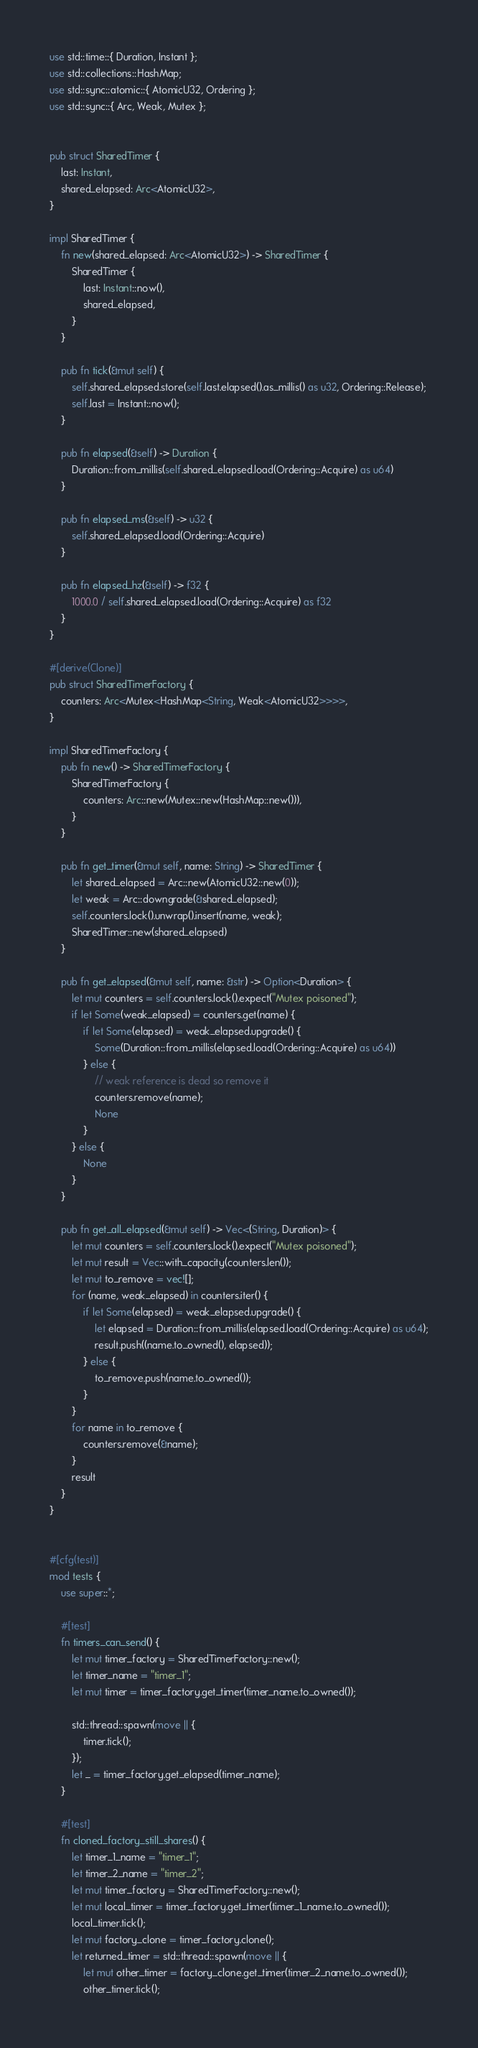Convert code to text. <code><loc_0><loc_0><loc_500><loc_500><_Rust_>use std::time::{ Duration, Instant };
use std::collections::HashMap;
use std::sync::atomic::{ AtomicU32, Ordering };
use std::sync::{ Arc, Weak, Mutex };


pub struct SharedTimer {
    last: Instant,
    shared_elapsed: Arc<AtomicU32>,
}

impl SharedTimer {
    fn new(shared_elapsed: Arc<AtomicU32>) -> SharedTimer {
        SharedTimer {
            last: Instant::now(),
            shared_elapsed,
        }
    }

    pub fn tick(&mut self) {
        self.shared_elapsed.store(self.last.elapsed().as_millis() as u32, Ordering::Release);
        self.last = Instant::now();
    }

    pub fn elapsed(&self) -> Duration {
        Duration::from_millis(self.shared_elapsed.load(Ordering::Acquire) as u64)
    }

    pub fn elapsed_ms(&self) -> u32 {
        self.shared_elapsed.load(Ordering::Acquire)
    }

    pub fn elapsed_hz(&self) -> f32 {
        1000.0 / self.shared_elapsed.load(Ordering::Acquire) as f32
    }
}

#[derive(Clone)]
pub struct SharedTimerFactory {
    counters: Arc<Mutex<HashMap<String, Weak<AtomicU32>>>>,
}

impl SharedTimerFactory {
    pub fn new() -> SharedTimerFactory {
        SharedTimerFactory {
            counters: Arc::new(Mutex::new(HashMap::new())),
        }
    }

    pub fn get_timer(&mut self, name: String) -> SharedTimer {
        let shared_elapsed = Arc::new(AtomicU32::new(0));
        let weak = Arc::downgrade(&shared_elapsed);
        self.counters.lock().unwrap().insert(name, weak);
        SharedTimer::new(shared_elapsed)
    }

    pub fn get_elapsed(&mut self, name: &str) -> Option<Duration> {
        let mut counters = self.counters.lock().expect("Mutex poisoned");
        if let Some(weak_elapsed) = counters.get(name) {
            if let Some(elapsed) = weak_elapsed.upgrade() {
                Some(Duration::from_millis(elapsed.load(Ordering::Acquire) as u64))
            } else {
                // weak reference is dead so remove it
                counters.remove(name);
                None
            }
        } else {
            None
        }
    }

    pub fn get_all_elapsed(&mut self) -> Vec<(String, Duration)> {
        let mut counters = self.counters.lock().expect("Mutex poisoned");
        let mut result = Vec::with_capacity(counters.len());
        let mut to_remove = vec![];
        for (name, weak_elapsed) in counters.iter() {
            if let Some(elapsed) = weak_elapsed.upgrade() {
                let elapsed = Duration::from_millis(elapsed.load(Ordering::Acquire) as u64);
                result.push((name.to_owned(), elapsed));
            } else {
                to_remove.push(name.to_owned());
            }
        }
        for name in to_remove {
            counters.remove(&name);
        }
        result
    }
}


#[cfg(test)]
mod tests {
    use super::*;

    #[test]
    fn timers_can_send() {
        let mut timer_factory = SharedTimerFactory::new();
        let timer_name = "timer_1";
        let mut timer = timer_factory.get_timer(timer_name.to_owned());

        std::thread::spawn(move || {
            timer.tick();
        });
        let _ = timer_factory.get_elapsed(timer_name);
    }

    #[test]
    fn cloned_factory_still_shares() {
        let timer_1_name = "timer_1";
        let timer_2_name = "timer_2";
        let mut timer_factory = SharedTimerFactory::new();
        let mut local_timer = timer_factory.get_timer(timer_1_name.to_owned());
        local_timer.tick();
        let mut factory_clone = timer_factory.clone();
        let returned_timer = std::thread::spawn(move || {
            let mut other_timer = factory_clone.get_timer(timer_2_name.to_owned());
            other_timer.tick();</code> 